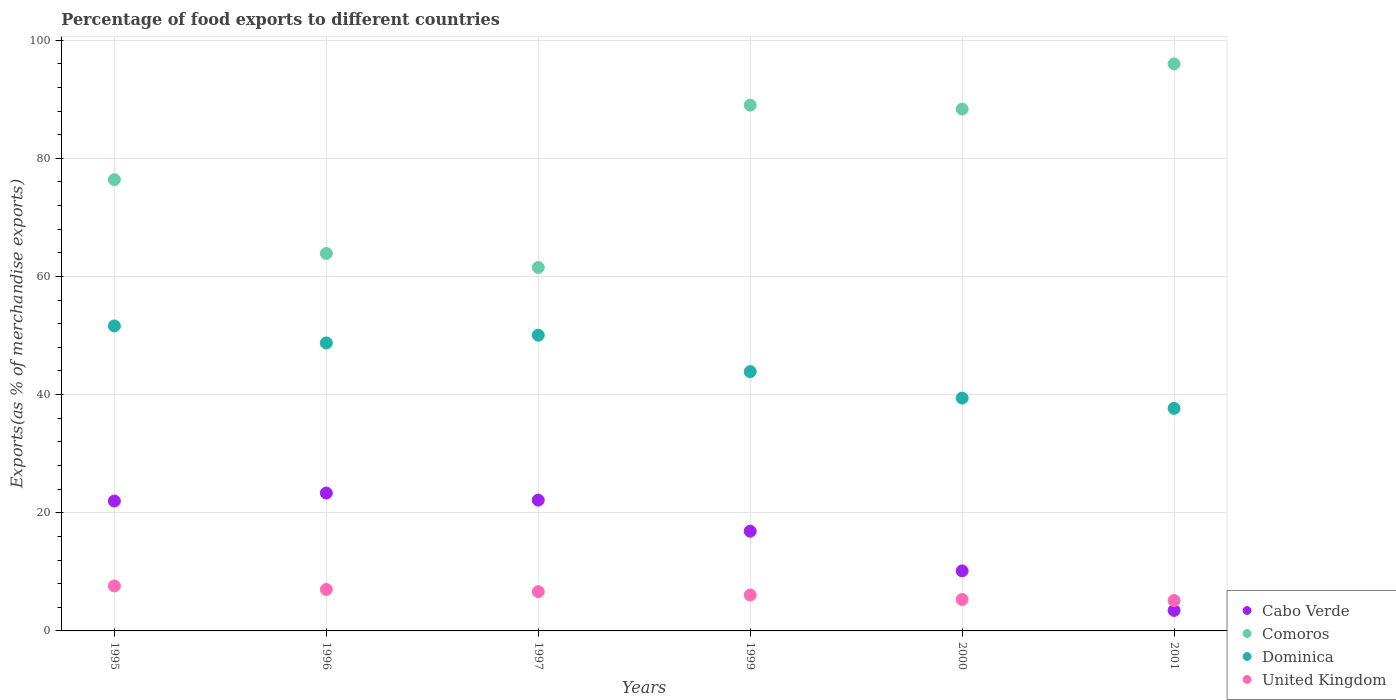What is the percentage of exports to different countries in Cabo Verde in 2000?
Provide a short and direct response. 10.16. Across all years, what is the maximum percentage of exports to different countries in United Kingdom?
Provide a succinct answer. 7.61. Across all years, what is the minimum percentage of exports to different countries in United Kingdom?
Offer a very short reply. 5.14. In which year was the percentage of exports to different countries in Cabo Verde maximum?
Offer a very short reply. 1996. What is the total percentage of exports to different countries in Comoros in the graph?
Offer a terse response. 475.1. What is the difference between the percentage of exports to different countries in Comoros in 1999 and that in 2001?
Provide a short and direct response. -6.99. What is the difference between the percentage of exports to different countries in United Kingdom in 1995 and the percentage of exports to different countries in Cabo Verde in 2000?
Offer a very short reply. -2.55. What is the average percentage of exports to different countries in Cabo Verde per year?
Give a very brief answer. 16.33. In the year 2001, what is the difference between the percentage of exports to different countries in Comoros and percentage of exports to different countries in Cabo Verde?
Provide a succinct answer. 92.51. In how many years, is the percentage of exports to different countries in Cabo Verde greater than 24 %?
Provide a succinct answer. 0. What is the ratio of the percentage of exports to different countries in United Kingdom in 2000 to that in 2001?
Ensure brevity in your answer.  1.03. What is the difference between the highest and the second highest percentage of exports to different countries in Cabo Verde?
Offer a terse response. 1.19. What is the difference between the highest and the lowest percentage of exports to different countries in United Kingdom?
Provide a succinct answer. 2.47. Is it the case that in every year, the sum of the percentage of exports to different countries in United Kingdom and percentage of exports to different countries in Comoros  is greater than the sum of percentage of exports to different countries in Dominica and percentage of exports to different countries in Cabo Verde?
Your answer should be very brief. Yes. Does the percentage of exports to different countries in Cabo Verde monotonically increase over the years?
Make the answer very short. No. What is the difference between two consecutive major ticks on the Y-axis?
Offer a terse response. 20. Where does the legend appear in the graph?
Ensure brevity in your answer.  Bottom right. How are the legend labels stacked?
Your answer should be compact. Vertical. What is the title of the graph?
Your response must be concise. Percentage of food exports to different countries. What is the label or title of the X-axis?
Offer a terse response. Years. What is the label or title of the Y-axis?
Provide a short and direct response. Exports(as % of merchandise exports). What is the Exports(as % of merchandise exports) of Cabo Verde in 1995?
Keep it short and to the point. 21.99. What is the Exports(as % of merchandise exports) in Comoros in 1995?
Give a very brief answer. 76.39. What is the Exports(as % of merchandise exports) of Dominica in 1995?
Provide a short and direct response. 51.63. What is the Exports(as % of merchandise exports) in United Kingdom in 1995?
Keep it short and to the point. 7.61. What is the Exports(as % of merchandise exports) of Cabo Verde in 1996?
Give a very brief answer. 23.33. What is the Exports(as % of merchandise exports) in Comoros in 1996?
Give a very brief answer. 63.89. What is the Exports(as % of merchandise exports) of Dominica in 1996?
Provide a succinct answer. 48.75. What is the Exports(as % of merchandise exports) in United Kingdom in 1996?
Your answer should be very brief. 7.02. What is the Exports(as % of merchandise exports) of Cabo Verde in 1997?
Offer a terse response. 22.14. What is the Exports(as % of merchandise exports) of Comoros in 1997?
Your answer should be compact. 61.52. What is the Exports(as % of merchandise exports) of Dominica in 1997?
Your answer should be compact. 50.06. What is the Exports(as % of merchandise exports) in United Kingdom in 1997?
Ensure brevity in your answer.  6.64. What is the Exports(as % of merchandise exports) in Cabo Verde in 1999?
Ensure brevity in your answer.  16.88. What is the Exports(as % of merchandise exports) of Comoros in 1999?
Make the answer very short. 88.99. What is the Exports(as % of merchandise exports) of Dominica in 1999?
Make the answer very short. 43.89. What is the Exports(as % of merchandise exports) in United Kingdom in 1999?
Give a very brief answer. 6.08. What is the Exports(as % of merchandise exports) of Cabo Verde in 2000?
Give a very brief answer. 10.16. What is the Exports(as % of merchandise exports) of Comoros in 2000?
Offer a very short reply. 88.33. What is the Exports(as % of merchandise exports) in Dominica in 2000?
Your answer should be very brief. 39.41. What is the Exports(as % of merchandise exports) of United Kingdom in 2000?
Provide a succinct answer. 5.32. What is the Exports(as % of merchandise exports) in Cabo Verde in 2001?
Keep it short and to the point. 3.47. What is the Exports(as % of merchandise exports) in Comoros in 2001?
Your response must be concise. 95.98. What is the Exports(as % of merchandise exports) in Dominica in 2001?
Offer a terse response. 37.66. What is the Exports(as % of merchandise exports) in United Kingdom in 2001?
Give a very brief answer. 5.14. Across all years, what is the maximum Exports(as % of merchandise exports) of Cabo Verde?
Give a very brief answer. 23.33. Across all years, what is the maximum Exports(as % of merchandise exports) of Comoros?
Ensure brevity in your answer.  95.98. Across all years, what is the maximum Exports(as % of merchandise exports) in Dominica?
Your answer should be very brief. 51.63. Across all years, what is the maximum Exports(as % of merchandise exports) of United Kingdom?
Your answer should be very brief. 7.61. Across all years, what is the minimum Exports(as % of merchandise exports) in Cabo Verde?
Offer a very short reply. 3.47. Across all years, what is the minimum Exports(as % of merchandise exports) in Comoros?
Your response must be concise. 61.52. Across all years, what is the minimum Exports(as % of merchandise exports) in Dominica?
Provide a succinct answer. 37.66. Across all years, what is the minimum Exports(as % of merchandise exports) of United Kingdom?
Ensure brevity in your answer.  5.14. What is the total Exports(as % of merchandise exports) of Cabo Verde in the graph?
Provide a short and direct response. 97.97. What is the total Exports(as % of merchandise exports) of Comoros in the graph?
Provide a short and direct response. 475.1. What is the total Exports(as % of merchandise exports) in Dominica in the graph?
Provide a short and direct response. 271.4. What is the total Exports(as % of merchandise exports) in United Kingdom in the graph?
Offer a terse response. 37.82. What is the difference between the Exports(as % of merchandise exports) of Cabo Verde in 1995 and that in 1996?
Give a very brief answer. -1.35. What is the difference between the Exports(as % of merchandise exports) of Comoros in 1995 and that in 1996?
Offer a terse response. 12.5. What is the difference between the Exports(as % of merchandise exports) in Dominica in 1995 and that in 1996?
Ensure brevity in your answer.  2.88. What is the difference between the Exports(as % of merchandise exports) of United Kingdom in 1995 and that in 1996?
Provide a short and direct response. 0.6. What is the difference between the Exports(as % of merchandise exports) of Cabo Verde in 1995 and that in 1997?
Make the answer very short. -0.16. What is the difference between the Exports(as % of merchandise exports) of Comoros in 1995 and that in 1997?
Ensure brevity in your answer.  14.87. What is the difference between the Exports(as % of merchandise exports) of Dominica in 1995 and that in 1997?
Ensure brevity in your answer.  1.57. What is the difference between the Exports(as % of merchandise exports) in United Kingdom in 1995 and that in 1997?
Your answer should be compact. 0.97. What is the difference between the Exports(as % of merchandise exports) of Cabo Verde in 1995 and that in 1999?
Ensure brevity in your answer.  5.11. What is the difference between the Exports(as % of merchandise exports) in Comoros in 1995 and that in 1999?
Give a very brief answer. -12.6. What is the difference between the Exports(as % of merchandise exports) of Dominica in 1995 and that in 1999?
Provide a succinct answer. 7.73. What is the difference between the Exports(as % of merchandise exports) in United Kingdom in 1995 and that in 1999?
Make the answer very short. 1.53. What is the difference between the Exports(as % of merchandise exports) in Cabo Verde in 1995 and that in 2000?
Offer a terse response. 11.82. What is the difference between the Exports(as % of merchandise exports) in Comoros in 1995 and that in 2000?
Ensure brevity in your answer.  -11.94. What is the difference between the Exports(as % of merchandise exports) of Dominica in 1995 and that in 2000?
Ensure brevity in your answer.  12.22. What is the difference between the Exports(as % of merchandise exports) in United Kingdom in 1995 and that in 2000?
Ensure brevity in your answer.  2.3. What is the difference between the Exports(as % of merchandise exports) in Cabo Verde in 1995 and that in 2001?
Offer a very short reply. 18.51. What is the difference between the Exports(as % of merchandise exports) in Comoros in 1995 and that in 2001?
Provide a short and direct response. -19.59. What is the difference between the Exports(as % of merchandise exports) of Dominica in 1995 and that in 2001?
Provide a succinct answer. 13.96. What is the difference between the Exports(as % of merchandise exports) in United Kingdom in 1995 and that in 2001?
Your answer should be compact. 2.47. What is the difference between the Exports(as % of merchandise exports) in Cabo Verde in 1996 and that in 1997?
Provide a succinct answer. 1.19. What is the difference between the Exports(as % of merchandise exports) of Comoros in 1996 and that in 1997?
Provide a succinct answer. 2.36. What is the difference between the Exports(as % of merchandise exports) in Dominica in 1996 and that in 1997?
Offer a very short reply. -1.31. What is the difference between the Exports(as % of merchandise exports) of United Kingdom in 1996 and that in 1997?
Your answer should be compact. 0.37. What is the difference between the Exports(as % of merchandise exports) in Cabo Verde in 1996 and that in 1999?
Keep it short and to the point. 6.45. What is the difference between the Exports(as % of merchandise exports) in Comoros in 1996 and that in 1999?
Make the answer very short. -25.1. What is the difference between the Exports(as % of merchandise exports) of Dominica in 1996 and that in 1999?
Keep it short and to the point. 4.86. What is the difference between the Exports(as % of merchandise exports) in United Kingdom in 1996 and that in 1999?
Your answer should be very brief. 0.93. What is the difference between the Exports(as % of merchandise exports) of Cabo Verde in 1996 and that in 2000?
Offer a very short reply. 13.17. What is the difference between the Exports(as % of merchandise exports) of Comoros in 1996 and that in 2000?
Offer a very short reply. -24.45. What is the difference between the Exports(as % of merchandise exports) in Dominica in 1996 and that in 2000?
Your response must be concise. 9.34. What is the difference between the Exports(as % of merchandise exports) in United Kingdom in 1996 and that in 2000?
Give a very brief answer. 1.7. What is the difference between the Exports(as % of merchandise exports) of Cabo Verde in 1996 and that in 2001?
Offer a very short reply. 19.86. What is the difference between the Exports(as % of merchandise exports) of Comoros in 1996 and that in 2001?
Your answer should be very brief. -32.09. What is the difference between the Exports(as % of merchandise exports) of Dominica in 1996 and that in 2001?
Keep it short and to the point. 11.08. What is the difference between the Exports(as % of merchandise exports) of United Kingdom in 1996 and that in 2001?
Give a very brief answer. 1.87. What is the difference between the Exports(as % of merchandise exports) of Cabo Verde in 1997 and that in 1999?
Give a very brief answer. 5.26. What is the difference between the Exports(as % of merchandise exports) of Comoros in 1997 and that in 1999?
Your response must be concise. -27.47. What is the difference between the Exports(as % of merchandise exports) in Dominica in 1997 and that in 1999?
Your response must be concise. 6.16. What is the difference between the Exports(as % of merchandise exports) in United Kingdom in 1997 and that in 1999?
Your answer should be very brief. 0.56. What is the difference between the Exports(as % of merchandise exports) in Cabo Verde in 1997 and that in 2000?
Your answer should be very brief. 11.98. What is the difference between the Exports(as % of merchandise exports) of Comoros in 1997 and that in 2000?
Provide a short and direct response. -26.81. What is the difference between the Exports(as % of merchandise exports) in Dominica in 1997 and that in 2000?
Your answer should be compact. 10.65. What is the difference between the Exports(as % of merchandise exports) of United Kingdom in 1997 and that in 2000?
Offer a terse response. 1.33. What is the difference between the Exports(as % of merchandise exports) in Cabo Verde in 1997 and that in 2001?
Your response must be concise. 18.67. What is the difference between the Exports(as % of merchandise exports) in Comoros in 1997 and that in 2001?
Provide a short and direct response. -34.46. What is the difference between the Exports(as % of merchandise exports) of Dominica in 1997 and that in 2001?
Provide a succinct answer. 12.39. What is the difference between the Exports(as % of merchandise exports) of United Kingdom in 1997 and that in 2001?
Give a very brief answer. 1.5. What is the difference between the Exports(as % of merchandise exports) of Cabo Verde in 1999 and that in 2000?
Offer a terse response. 6.72. What is the difference between the Exports(as % of merchandise exports) in Comoros in 1999 and that in 2000?
Keep it short and to the point. 0.66. What is the difference between the Exports(as % of merchandise exports) in Dominica in 1999 and that in 2000?
Keep it short and to the point. 4.48. What is the difference between the Exports(as % of merchandise exports) of United Kingdom in 1999 and that in 2000?
Offer a very short reply. 0.77. What is the difference between the Exports(as % of merchandise exports) in Cabo Verde in 1999 and that in 2001?
Provide a short and direct response. 13.41. What is the difference between the Exports(as % of merchandise exports) of Comoros in 1999 and that in 2001?
Provide a succinct answer. -6.99. What is the difference between the Exports(as % of merchandise exports) of Dominica in 1999 and that in 2001?
Give a very brief answer. 6.23. What is the difference between the Exports(as % of merchandise exports) in United Kingdom in 1999 and that in 2001?
Make the answer very short. 0.94. What is the difference between the Exports(as % of merchandise exports) in Cabo Verde in 2000 and that in 2001?
Ensure brevity in your answer.  6.69. What is the difference between the Exports(as % of merchandise exports) of Comoros in 2000 and that in 2001?
Provide a succinct answer. -7.65. What is the difference between the Exports(as % of merchandise exports) in Dominica in 2000 and that in 2001?
Offer a terse response. 1.75. What is the difference between the Exports(as % of merchandise exports) of United Kingdom in 2000 and that in 2001?
Your answer should be compact. 0.17. What is the difference between the Exports(as % of merchandise exports) in Cabo Verde in 1995 and the Exports(as % of merchandise exports) in Comoros in 1996?
Your answer should be very brief. -41.9. What is the difference between the Exports(as % of merchandise exports) of Cabo Verde in 1995 and the Exports(as % of merchandise exports) of Dominica in 1996?
Provide a short and direct response. -26.76. What is the difference between the Exports(as % of merchandise exports) of Cabo Verde in 1995 and the Exports(as % of merchandise exports) of United Kingdom in 1996?
Ensure brevity in your answer.  14.97. What is the difference between the Exports(as % of merchandise exports) in Comoros in 1995 and the Exports(as % of merchandise exports) in Dominica in 1996?
Provide a short and direct response. 27.64. What is the difference between the Exports(as % of merchandise exports) of Comoros in 1995 and the Exports(as % of merchandise exports) of United Kingdom in 1996?
Your answer should be very brief. 69.37. What is the difference between the Exports(as % of merchandise exports) in Dominica in 1995 and the Exports(as % of merchandise exports) in United Kingdom in 1996?
Give a very brief answer. 44.61. What is the difference between the Exports(as % of merchandise exports) of Cabo Verde in 1995 and the Exports(as % of merchandise exports) of Comoros in 1997?
Give a very brief answer. -39.54. What is the difference between the Exports(as % of merchandise exports) in Cabo Verde in 1995 and the Exports(as % of merchandise exports) in Dominica in 1997?
Your response must be concise. -28.07. What is the difference between the Exports(as % of merchandise exports) in Cabo Verde in 1995 and the Exports(as % of merchandise exports) in United Kingdom in 1997?
Ensure brevity in your answer.  15.34. What is the difference between the Exports(as % of merchandise exports) in Comoros in 1995 and the Exports(as % of merchandise exports) in Dominica in 1997?
Your answer should be very brief. 26.33. What is the difference between the Exports(as % of merchandise exports) in Comoros in 1995 and the Exports(as % of merchandise exports) in United Kingdom in 1997?
Make the answer very short. 69.74. What is the difference between the Exports(as % of merchandise exports) of Dominica in 1995 and the Exports(as % of merchandise exports) of United Kingdom in 1997?
Ensure brevity in your answer.  44.98. What is the difference between the Exports(as % of merchandise exports) in Cabo Verde in 1995 and the Exports(as % of merchandise exports) in Comoros in 1999?
Keep it short and to the point. -67. What is the difference between the Exports(as % of merchandise exports) in Cabo Verde in 1995 and the Exports(as % of merchandise exports) in Dominica in 1999?
Ensure brevity in your answer.  -21.91. What is the difference between the Exports(as % of merchandise exports) in Cabo Verde in 1995 and the Exports(as % of merchandise exports) in United Kingdom in 1999?
Ensure brevity in your answer.  15.9. What is the difference between the Exports(as % of merchandise exports) of Comoros in 1995 and the Exports(as % of merchandise exports) of Dominica in 1999?
Give a very brief answer. 32.5. What is the difference between the Exports(as % of merchandise exports) of Comoros in 1995 and the Exports(as % of merchandise exports) of United Kingdom in 1999?
Offer a very short reply. 70.31. What is the difference between the Exports(as % of merchandise exports) of Dominica in 1995 and the Exports(as % of merchandise exports) of United Kingdom in 1999?
Your response must be concise. 45.54. What is the difference between the Exports(as % of merchandise exports) of Cabo Verde in 1995 and the Exports(as % of merchandise exports) of Comoros in 2000?
Provide a succinct answer. -66.35. What is the difference between the Exports(as % of merchandise exports) of Cabo Verde in 1995 and the Exports(as % of merchandise exports) of Dominica in 2000?
Offer a terse response. -17.42. What is the difference between the Exports(as % of merchandise exports) in Cabo Verde in 1995 and the Exports(as % of merchandise exports) in United Kingdom in 2000?
Provide a succinct answer. 16.67. What is the difference between the Exports(as % of merchandise exports) in Comoros in 1995 and the Exports(as % of merchandise exports) in Dominica in 2000?
Your answer should be very brief. 36.98. What is the difference between the Exports(as % of merchandise exports) of Comoros in 1995 and the Exports(as % of merchandise exports) of United Kingdom in 2000?
Keep it short and to the point. 71.07. What is the difference between the Exports(as % of merchandise exports) of Dominica in 1995 and the Exports(as % of merchandise exports) of United Kingdom in 2000?
Ensure brevity in your answer.  46.31. What is the difference between the Exports(as % of merchandise exports) of Cabo Verde in 1995 and the Exports(as % of merchandise exports) of Comoros in 2001?
Offer a terse response. -73.99. What is the difference between the Exports(as % of merchandise exports) of Cabo Verde in 1995 and the Exports(as % of merchandise exports) of Dominica in 2001?
Keep it short and to the point. -15.68. What is the difference between the Exports(as % of merchandise exports) of Cabo Verde in 1995 and the Exports(as % of merchandise exports) of United Kingdom in 2001?
Make the answer very short. 16.84. What is the difference between the Exports(as % of merchandise exports) in Comoros in 1995 and the Exports(as % of merchandise exports) in Dominica in 2001?
Your answer should be very brief. 38.72. What is the difference between the Exports(as % of merchandise exports) of Comoros in 1995 and the Exports(as % of merchandise exports) of United Kingdom in 2001?
Offer a terse response. 71.25. What is the difference between the Exports(as % of merchandise exports) of Dominica in 1995 and the Exports(as % of merchandise exports) of United Kingdom in 2001?
Provide a succinct answer. 46.48. What is the difference between the Exports(as % of merchandise exports) in Cabo Verde in 1996 and the Exports(as % of merchandise exports) in Comoros in 1997?
Make the answer very short. -38.19. What is the difference between the Exports(as % of merchandise exports) in Cabo Verde in 1996 and the Exports(as % of merchandise exports) in Dominica in 1997?
Give a very brief answer. -26.73. What is the difference between the Exports(as % of merchandise exports) of Cabo Verde in 1996 and the Exports(as % of merchandise exports) of United Kingdom in 1997?
Ensure brevity in your answer.  16.69. What is the difference between the Exports(as % of merchandise exports) in Comoros in 1996 and the Exports(as % of merchandise exports) in Dominica in 1997?
Your answer should be very brief. 13.83. What is the difference between the Exports(as % of merchandise exports) of Comoros in 1996 and the Exports(as % of merchandise exports) of United Kingdom in 1997?
Keep it short and to the point. 57.24. What is the difference between the Exports(as % of merchandise exports) of Dominica in 1996 and the Exports(as % of merchandise exports) of United Kingdom in 1997?
Offer a very short reply. 42.1. What is the difference between the Exports(as % of merchandise exports) of Cabo Verde in 1996 and the Exports(as % of merchandise exports) of Comoros in 1999?
Your answer should be very brief. -65.66. What is the difference between the Exports(as % of merchandise exports) of Cabo Verde in 1996 and the Exports(as % of merchandise exports) of Dominica in 1999?
Provide a short and direct response. -20.56. What is the difference between the Exports(as % of merchandise exports) in Cabo Verde in 1996 and the Exports(as % of merchandise exports) in United Kingdom in 1999?
Give a very brief answer. 17.25. What is the difference between the Exports(as % of merchandise exports) in Comoros in 1996 and the Exports(as % of merchandise exports) in Dominica in 1999?
Provide a succinct answer. 19.99. What is the difference between the Exports(as % of merchandise exports) in Comoros in 1996 and the Exports(as % of merchandise exports) in United Kingdom in 1999?
Make the answer very short. 57.8. What is the difference between the Exports(as % of merchandise exports) in Dominica in 1996 and the Exports(as % of merchandise exports) in United Kingdom in 1999?
Your response must be concise. 42.67. What is the difference between the Exports(as % of merchandise exports) in Cabo Verde in 1996 and the Exports(as % of merchandise exports) in Comoros in 2000?
Give a very brief answer. -65. What is the difference between the Exports(as % of merchandise exports) of Cabo Verde in 1996 and the Exports(as % of merchandise exports) of Dominica in 2000?
Make the answer very short. -16.08. What is the difference between the Exports(as % of merchandise exports) of Cabo Verde in 1996 and the Exports(as % of merchandise exports) of United Kingdom in 2000?
Make the answer very short. 18.02. What is the difference between the Exports(as % of merchandise exports) in Comoros in 1996 and the Exports(as % of merchandise exports) in Dominica in 2000?
Keep it short and to the point. 24.48. What is the difference between the Exports(as % of merchandise exports) in Comoros in 1996 and the Exports(as % of merchandise exports) in United Kingdom in 2000?
Ensure brevity in your answer.  58.57. What is the difference between the Exports(as % of merchandise exports) of Dominica in 1996 and the Exports(as % of merchandise exports) of United Kingdom in 2000?
Keep it short and to the point. 43.43. What is the difference between the Exports(as % of merchandise exports) in Cabo Verde in 1996 and the Exports(as % of merchandise exports) in Comoros in 2001?
Provide a short and direct response. -72.65. What is the difference between the Exports(as % of merchandise exports) in Cabo Verde in 1996 and the Exports(as % of merchandise exports) in Dominica in 2001?
Make the answer very short. -14.33. What is the difference between the Exports(as % of merchandise exports) in Cabo Verde in 1996 and the Exports(as % of merchandise exports) in United Kingdom in 2001?
Offer a very short reply. 18.19. What is the difference between the Exports(as % of merchandise exports) in Comoros in 1996 and the Exports(as % of merchandise exports) in Dominica in 2001?
Keep it short and to the point. 26.22. What is the difference between the Exports(as % of merchandise exports) of Comoros in 1996 and the Exports(as % of merchandise exports) of United Kingdom in 2001?
Provide a succinct answer. 58.74. What is the difference between the Exports(as % of merchandise exports) in Dominica in 1996 and the Exports(as % of merchandise exports) in United Kingdom in 2001?
Your response must be concise. 43.61. What is the difference between the Exports(as % of merchandise exports) in Cabo Verde in 1997 and the Exports(as % of merchandise exports) in Comoros in 1999?
Make the answer very short. -66.85. What is the difference between the Exports(as % of merchandise exports) in Cabo Verde in 1997 and the Exports(as % of merchandise exports) in Dominica in 1999?
Give a very brief answer. -21.75. What is the difference between the Exports(as % of merchandise exports) in Cabo Verde in 1997 and the Exports(as % of merchandise exports) in United Kingdom in 1999?
Your response must be concise. 16.06. What is the difference between the Exports(as % of merchandise exports) in Comoros in 1997 and the Exports(as % of merchandise exports) in Dominica in 1999?
Give a very brief answer. 17.63. What is the difference between the Exports(as % of merchandise exports) in Comoros in 1997 and the Exports(as % of merchandise exports) in United Kingdom in 1999?
Ensure brevity in your answer.  55.44. What is the difference between the Exports(as % of merchandise exports) in Dominica in 1997 and the Exports(as % of merchandise exports) in United Kingdom in 1999?
Make the answer very short. 43.97. What is the difference between the Exports(as % of merchandise exports) of Cabo Verde in 1997 and the Exports(as % of merchandise exports) of Comoros in 2000?
Provide a short and direct response. -66.19. What is the difference between the Exports(as % of merchandise exports) of Cabo Verde in 1997 and the Exports(as % of merchandise exports) of Dominica in 2000?
Give a very brief answer. -17.27. What is the difference between the Exports(as % of merchandise exports) in Cabo Verde in 1997 and the Exports(as % of merchandise exports) in United Kingdom in 2000?
Provide a short and direct response. 16.82. What is the difference between the Exports(as % of merchandise exports) of Comoros in 1997 and the Exports(as % of merchandise exports) of Dominica in 2000?
Your answer should be very brief. 22.11. What is the difference between the Exports(as % of merchandise exports) in Comoros in 1997 and the Exports(as % of merchandise exports) in United Kingdom in 2000?
Provide a succinct answer. 56.21. What is the difference between the Exports(as % of merchandise exports) in Dominica in 1997 and the Exports(as % of merchandise exports) in United Kingdom in 2000?
Keep it short and to the point. 44.74. What is the difference between the Exports(as % of merchandise exports) of Cabo Verde in 1997 and the Exports(as % of merchandise exports) of Comoros in 2001?
Your response must be concise. -73.84. What is the difference between the Exports(as % of merchandise exports) in Cabo Verde in 1997 and the Exports(as % of merchandise exports) in Dominica in 2001?
Keep it short and to the point. -15.52. What is the difference between the Exports(as % of merchandise exports) in Cabo Verde in 1997 and the Exports(as % of merchandise exports) in United Kingdom in 2001?
Ensure brevity in your answer.  17. What is the difference between the Exports(as % of merchandise exports) of Comoros in 1997 and the Exports(as % of merchandise exports) of Dominica in 2001?
Provide a succinct answer. 23.86. What is the difference between the Exports(as % of merchandise exports) of Comoros in 1997 and the Exports(as % of merchandise exports) of United Kingdom in 2001?
Offer a terse response. 56.38. What is the difference between the Exports(as % of merchandise exports) in Dominica in 1997 and the Exports(as % of merchandise exports) in United Kingdom in 2001?
Give a very brief answer. 44.91. What is the difference between the Exports(as % of merchandise exports) of Cabo Verde in 1999 and the Exports(as % of merchandise exports) of Comoros in 2000?
Your answer should be compact. -71.45. What is the difference between the Exports(as % of merchandise exports) in Cabo Verde in 1999 and the Exports(as % of merchandise exports) in Dominica in 2000?
Provide a short and direct response. -22.53. What is the difference between the Exports(as % of merchandise exports) of Cabo Verde in 1999 and the Exports(as % of merchandise exports) of United Kingdom in 2000?
Make the answer very short. 11.56. What is the difference between the Exports(as % of merchandise exports) in Comoros in 1999 and the Exports(as % of merchandise exports) in Dominica in 2000?
Offer a very short reply. 49.58. What is the difference between the Exports(as % of merchandise exports) of Comoros in 1999 and the Exports(as % of merchandise exports) of United Kingdom in 2000?
Your answer should be very brief. 83.67. What is the difference between the Exports(as % of merchandise exports) of Dominica in 1999 and the Exports(as % of merchandise exports) of United Kingdom in 2000?
Your response must be concise. 38.58. What is the difference between the Exports(as % of merchandise exports) of Cabo Verde in 1999 and the Exports(as % of merchandise exports) of Comoros in 2001?
Your answer should be compact. -79.1. What is the difference between the Exports(as % of merchandise exports) of Cabo Verde in 1999 and the Exports(as % of merchandise exports) of Dominica in 2001?
Provide a succinct answer. -20.79. What is the difference between the Exports(as % of merchandise exports) of Cabo Verde in 1999 and the Exports(as % of merchandise exports) of United Kingdom in 2001?
Give a very brief answer. 11.74. What is the difference between the Exports(as % of merchandise exports) in Comoros in 1999 and the Exports(as % of merchandise exports) in Dominica in 2001?
Give a very brief answer. 51.32. What is the difference between the Exports(as % of merchandise exports) of Comoros in 1999 and the Exports(as % of merchandise exports) of United Kingdom in 2001?
Make the answer very short. 83.85. What is the difference between the Exports(as % of merchandise exports) of Dominica in 1999 and the Exports(as % of merchandise exports) of United Kingdom in 2001?
Ensure brevity in your answer.  38.75. What is the difference between the Exports(as % of merchandise exports) in Cabo Verde in 2000 and the Exports(as % of merchandise exports) in Comoros in 2001?
Your answer should be very brief. -85.82. What is the difference between the Exports(as % of merchandise exports) of Cabo Verde in 2000 and the Exports(as % of merchandise exports) of Dominica in 2001?
Ensure brevity in your answer.  -27.5. What is the difference between the Exports(as % of merchandise exports) of Cabo Verde in 2000 and the Exports(as % of merchandise exports) of United Kingdom in 2001?
Your answer should be compact. 5.02. What is the difference between the Exports(as % of merchandise exports) in Comoros in 2000 and the Exports(as % of merchandise exports) in Dominica in 2001?
Give a very brief answer. 50.67. What is the difference between the Exports(as % of merchandise exports) in Comoros in 2000 and the Exports(as % of merchandise exports) in United Kingdom in 2001?
Offer a terse response. 83.19. What is the difference between the Exports(as % of merchandise exports) in Dominica in 2000 and the Exports(as % of merchandise exports) in United Kingdom in 2001?
Your response must be concise. 34.27. What is the average Exports(as % of merchandise exports) of Cabo Verde per year?
Make the answer very short. 16.33. What is the average Exports(as % of merchandise exports) of Comoros per year?
Ensure brevity in your answer.  79.18. What is the average Exports(as % of merchandise exports) of Dominica per year?
Make the answer very short. 45.23. What is the average Exports(as % of merchandise exports) of United Kingdom per year?
Your answer should be compact. 6.3. In the year 1995, what is the difference between the Exports(as % of merchandise exports) of Cabo Verde and Exports(as % of merchandise exports) of Comoros?
Keep it short and to the point. -54.4. In the year 1995, what is the difference between the Exports(as % of merchandise exports) of Cabo Verde and Exports(as % of merchandise exports) of Dominica?
Provide a short and direct response. -29.64. In the year 1995, what is the difference between the Exports(as % of merchandise exports) in Cabo Verde and Exports(as % of merchandise exports) in United Kingdom?
Your answer should be very brief. 14.37. In the year 1995, what is the difference between the Exports(as % of merchandise exports) of Comoros and Exports(as % of merchandise exports) of Dominica?
Give a very brief answer. 24.76. In the year 1995, what is the difference between the Exports(as % of merchandise exports) in Comoros and Exports(as % of merchandise exports) in United Kingdom?
Give a very brief answer. 68.78. In the year 1995, what is the difference between the Exports(as % of merchandise exports) in Dominica and Exports(as % of merchandise exports) in United Kingdom?
Your response must be concise. 44.01. In the year 1996, what is the difference between the Exports(as % of merchandise exports) in Cabo Verde and Exports(as % of merchandise exports) in Comoros?
Your response must be concise. -40.55. In the year 1996, what is the difference between the Exports(as % of merchandise exports) of Cabo Verde and Exports(as % of merchandise exports) of Dominica?
Your response must be concise. -25.42. In the year 1996, what is the difference between the Exports(as % of merchandise exports) of Cabo Verde and Exports(as % of merchandise exports) of United Kingdom?
Offer a terse response. 16.32. In the year 1996, what is the difference between the Exports(as % of merchandise exports) of Comoros and Exports(as % of merchandise exports) of Dominica?
Give a very brief answer. 15.14. In the year 1996, what is the difference between the Exports(as % of merchandise exports) of Comoros and Exports(as % of merchandise exports) of United Kingdom?
Keep it short and to the point. 56.87. In the year 1996, what is the difference between the Exports(as % of merchandise exports) in Dominica and Exports(as % of merchandise exports) in United Kingdom?
Provide a succinct answer. 41.73. In the year 1997, what is the difference between the Exports(as % of merchandise exports) of Cabo Verde and Exports(as % of merchandise exports) of Comoros?
Your response must be concise. -39.38. In the year 1997, what is the difference between the Exports(as % of merchandise exports) in Cabo Verde and Exports(as % of merchandise exports) in Dominica?
Provide a succinct answer. -27.92. In the year 1997, what is the difference between the Exports(as % of merchandise exports) in Cabo Verde and Exports(as % of merchandise exports) in United Kingdom?
Provide a succinct answer. 15.5. In the year 1997, what is the difference between the Exports(as % of merchandise exports) of Comoros and Exports(as % of merchandise exports) of Dominica?
Your response must be concise. 11.47. In the year 1997, what is the difference between the Exports(as % of merchandise exports) in Comoros and Exports(as % of merchandise exports) in United Kingdom?
Your response must be concise. 54.88. In the year 1997, what is the difference between the Exports(as % of merchandise exports) of Dominica and Exports(as % of merchandise exports) of United Kingdom?
Offer a terse response. 43.41. In the year 1999, what is the difference between the Exports(as % of merchandise exports) of Cabo Verde and Exports(as % of merchandise exports) of Comoros?
Your answer should be very brief. -72.11. In the year 1999, what is the difference between the Exports(as % of merchandise exports) of Cabo Verde and Exports(as % of merchandise exports) of Dominica?
Make the answer very short. -27.02. In the year 1999, what is the difference between the Exports(as % of merchandise exports) of Cabo Verde and Exports(as % of merchandise exports) of United Kingdom?
Your answer should be compact. 10.8. In the year 1999, what is the difference between the Exports(as % of merchandise exports) in Comoros and Exports(as % of merchandise exports) in Dominica?
Offer a terse response. 45.1. In the year 1999, what is the difference between the Exports(as % of merchandise exports) of Comoros and Exports(as % of merchandise exports) of United Kingdom?
Keep it short and to the point. 82.91. In the year 1999, what is the difference between the Exports(as % of merchandise exports) of Dominica and Exports(as % of merchandise exports) of United Kingdom?
Keep it short and to the point. 37.81. In the year 2000, what is the difference between the Exports(as % of merchandise exports) of Cabo Verde and Exports(as % of merchandise exports) of Comoros?
Your response must be concise. -78.17. In the year 2000, what is the difference between the Exports(as % of merchandise exports) of Cabo Verde and Exports(as % of merchandise exports) of Dominica?
Provide a short and direct response. -29.25. In the year 2000, what is the difference between the Exports(as % of merchandise exports) of Cabo Verde and Exports(as % of merchandise exports) of United Kingdom?
Your answer should be compact. 4.84. In the year 2000, what is the difference between the Exports(as % of merchandise exports) in Comoros and Exports(as % of merchandise exports) in Dominica?
Give a very brief answer. 48.92. In the year 2000, what is the difference between the Exports(as % of merchandise exports) of Comoros and Exports(as % of merchandise exports) of United Kingdom?
Keep it short and to the point. 83.02. In the year 2000, what is the difference between the Exports(as % of merchandise exports) in Dominica and Exports(as % of merchandise exports) in United Kingdom?
Provide a succinct answer. 34.09. In the year 2001, what is the difference between the Exports(as % of merchandise exports) in Cabo Verde and Exports(as % of merchandise exports) in Comoros?
Offer a very short reply. -92.51. In the year 2001, what is the difference between the Exports(as % of merchandise exports) of Cabo Verde and Exports(as % of merchandise exports) of Dominica?
Keep it short and to the point. -34.19. In the year 2001, what is the difference between the Exports(as % of merchandise exports) in Cabo Verde and Exports(as % of merchandise exports) in United Kingdom?
Provide a short and direct response. -1.67. In the year 2001, what is the difference between the Exports(as % of merchandise exports) of Comoros and Exports(as % of merchandise exports) of Dominica?
Give a very brief answer. 58.31. In the year 2001, what is the difference between the Exports(as % of merchandise exports) of Comoros and Exports(as % of merchandise exports) of United Kingdom?
Provide a short and direct response. 90.84. In the year 2001, what is the difference between the Exports(as % of merchandise exports) in Dominica and Exports(as % of merchandise exports) in United Kingdom?
Give a very brief answer. 32.52. What is the ratio of the Exports(as % of merchandise exports) in Cabo Verde in 1995 to that in 1996?
Provide a short and direct response. 0.94. What is the ratio of the Exports(as % of merchandise exports) of Comoros in 1995 to that in 1996?
Offer a terse response. 1.2. What is the ratio of the Exports(as % of merchandise exports) of Dominica in 1995 to that in 1996?
Make the answer very short. 1.06. What is the ratio of the Exports(as % of merchandise exports) in United Kingdom in 1995 to that in 1996?
Make the answer very short. 1.09. What is the ratio of the Exports(as % of merchandise exports) in Cabo Verde in 1995 to that in 1997?
Ensure brevity in your answer.  0.99. What is the ratio of the Exports(as % of merchandise exports) of Comoros in 1995 to that in 1997?
Give a very brief answer. 1.24. What is the ratio of the Exports(as % of merchandise exports) in Dominica in 1995 to that in 1997?
Your answer should be compact. 1.03. What is the ratio of the Exports(as % of merchandise exports) of United Kingdom in 1995 to that in 1997?
Offer a very short reply. 1.15. What is the ratio of the Exports(as % of merchandise exports) of Cabo Verde in 1995 to that in 1999?
Offer a very short reply. 1.3. What is the ratio of the Exports(as % of merchandise exports) in Comoros in 1995 to that in 1999?
Offer a terse response. 0.86. What is the ratio of the Exports(as % of merchandise exports) in Dominica in 1995 to that in 1999?
Your answer should be compact. 1.18. What is the ratio of the Exports(as % of merchandise exports) of United Kingdom in 1995 to that in 1999?
Your answer should be very brief. 1.25. What is the ratio of the Exports(as % of merchandise exports) of Cabo Verde in 1995 to that in 2000?
Give a very brief answer. 2.16. What is the ratio of the Exports(as % of merchandise exports) in Comoros in 1995 to that in 2000?
Offer a terse response. 0.86. What is the ratio of the Exports(as % of merchandise exports) of Dominica in 1995 to that in 2000?
Give a very brief answer. 1.31. What is the ratio of the Exports(as % of merchandise exports) of United Kingdom in 1995 to that in 2000?
Your response must be concise. 1.43. What is the ratio of the Exports(as % of merchandise exports) in Cabo Verde in 1995 to that in 2001?
Your answer should be compact. 6.33. What is the ratio of the Exports(as % of merchandise exports) in Comoros in 1995 to that in 2001?
Provide a short and direct response. 0.8. What is the ratio of the Exports(as % of merchandise exports) in Dominica in 1995 to that in 2001?
Your answer should be very brief. 1.37. What is the ratio of the Exports(as % of merchandise exports) in United Kingdom in 1995 to that in 2001?
Offer a terse response. 1.48. What is the ratio of the Exports(as % of merchandise exports) in Cabo Verde in 1996 to that in 1997?
Keep it short and to the point. 1.05. What is the ratio of the Exports(as % of merchandise exports) in Comoros in 1996 to that in 1997?
Your answer should be compact. 1.04. What is the ratio of the Exports(as % of merchandise exports) in Dominica in 1996 to that in 1997?
Your response must be concise. 0.97. What is the ratio of the Exports(as % of merchandise exports) of United Kingdom in 1996 to that in 1997?
Keep it short and to the point. 1.06. What is the ratio of the Exports(as % of merchandise exports) of Cabo Verde in 1996 to that in 1999?
Give a very brief answer. 1.38. What is the ratio of the Exports(as % of merchandise exports) in Comoros in 1996 to that in 1999?
Keep it short and to the point. 0.72. What is the ratio of the Exports(as % of merchandise exports) in Dominica in 1996 to that in 1999?
Provide a succinct answer. 1.11. What is the ratio of the Exports(as % of merchandise exports) of United Kingdom in 1996 to that in 1999?
Ensure brevity in your answer.  1.15. What is the ratio of the Exports(as % of merchandise exports) in Cabo Verde in 1996 to that in 2000?
Ensure brevity in your answer.  2.3. What is the ratio of the Exports(as % of merchandise exports) in Comoros in 1996 to that in 2000?
Provide a short and direct response. 0.72. What is the ratio of the Exports(as % of merchandise exports) in Dominica in 1996 to that in 2000?
Give a very brief answer. 1.24. What is the ratio of the Exports(as % of merchandise exports) in United Kingdom in 1996 to that in 2000?
Your answer should be very brief. 1.32. What is the ratio of the Exports(as % of merchandise exports) of Cabo Verde in 1996 to that in 2001?
Provide a short and direct response. 6.72. What is the ratio of the Exports(as % of merchandise exports) in Comoros in 1996 to that in 2001?
Provide a short and direct response. 0.67. What is the ratio of the Exports(as % of merchandise exports) in Dominica in 1996 to that in 2001?
Your answer should be compact. 1.29. What is the ratio of the Exports(as % of merchandise exports) of United Kingdom in 1996 to that in 2001?
Provide a short and direct response. 1.36. What is the ratio of the Exports(as % of merchandise exports) of Cabo Verde in 1997 to that in 1999?
Offer a terse response. 1.31. What is the ratio of the Exports(as % of merchandise exports) in Comoros in 1997 to that in 1999?
Your answer should be very brief. 0.69. What is the ratio of the Exports(as % of merchandise exports) in Dominica in 1997 to that in 1999?
Offer a very short reply. 1.14. What is the ratio of the Exports(as % of merchandise exports) of United Kingdom in 1997 to that in 1999?
Keep it short and to the point. 1.09. What is the ratio of the Exports(as % of merchandise exports) of Cabo Verde in 1997 to that in 2000?
Your answer should be compact. 2.18. What is the ratio of the Exports(as % of merchandise exports) in Comoros in 1997 to that in 2000?
Provide a short and direct response. 0.7. What is the ratio of the Exports(as % of merchandise exports) in Dominica in 1997 to that in 2000?
Your response must be concise. 1.27. What is the ratio of the Exports(as % of merchandise exports) in United Kingdom in 1997 to that in 2000?
Keep it short and to the point. 1.25. What is the ratio of the Exports(as % of merchandise exports) of Cabo Verde in 1997 to that in 2001?
Ensure brevity in your answer.  6.38. What is the ratio of the Exports(as % of merchandise exports) of Comoros in 1997 to that in 2001?
Give a very brief answer. 0.64. What is the ratio of the Exports(as % of merchandise exports) in Dominica in 1997 to that in 2001?
Make the answer very short. 1.33. What is the ratio of the Exports(as % of merchandise exports) of United Kingdom in 1997 to that in 2001?
Provide a short and direct response. 1.29. What is the ratio of the Exports(as % of merchandise exports) of Cabo Verde in 1999 to that in 2000?
Keep it short and to the point. 1.66. What is the ratio of the Exports(as % of merchandise exports) in Comoros in 1999 to that in 2000?
Your answer should be very brief. 1.01. What is the ratio of the Exports(as % of merchandise exports) in Dominica in 1999 to that in 2000?
Keep it short and to the point. 1.11. What is the ratio of the Exports(as % of merchandise exports) of United Kingdom in 1999 to that in 2000?
Give a very brief answer. 1.14. What is the ratio of the Exports(as % of merchandise exports) in Cabo Verde in 1999 to that in 2001?
Offer a terse response. 4.86. What is the ratio of the Exports(as % of merchandise exports) in Comoros in 1999 to that in 2001?
Ensure brevity in your answer.  0.93. What is the ratio of the Exports(as % of merchandise exports) in Dominica in 1999 to that in 2001?
Your response must be concise. 1.17. What is the ratio of the Exports(as % of merchandise exports) in United Kingdom in 1999 to that in 2001?
Your answer should be very brief. 1.18. What is the ratio of the Exports(as % of merchandise exports) of Cabo Verde in 2000 to that in 2001?
Keep it short and to the point. 2.93. What is the ratio of the Exports(as % of merchandise exports) of Comoros in 2000 to that in 2001?
Your response must be concise. 0.92. What is the ratio of the Exports(as % of merchandise exports) in Dominica in 2000 to that in 2001?
Your response must be concise. 1.05. What is the ratio of the Exports(as % of merchandise exports) in United Kingdom in 2000 to that in 2001?
Offer a very short reply. 1.03. What is the difference between the highest and the second highest Exports(as % of merchandise exports) of Cabo Verde?
Keep it short and to the point. 1.19. What is the difference between the highest and the second highest Exports(as % of merchandise exports) in Comoros?
Ensure brevity in your answer.  6.99. What is the difference between the highest and the second highest Exports(as % of merchandise exports) in Dominica?
Offer a very short reply. 1.57. What is the difference between the highest and the second highest Exports(as % of merchandise exports) in United Kingdom?
Your answer should be very brief. 0.6. What is the difference between the highest and the lowest Exports(as % of merchandise exports) of Cabo Verde?
Your answer should be compact. 19.86. What is the difference between the highest and the lowest Exports(as % of merchandise exports) of Comoros?
Offer a terse response. 34.46. What is the difference between the highest and the lowest Exports(as % of merchandise exports) in Dominica?
Ensure brevity in your answer.  13.96. What is the difference between the highest and the lowest Exports(as % of merchandise exports) of United Kingdom?
Your response must be concise. 2.47. 